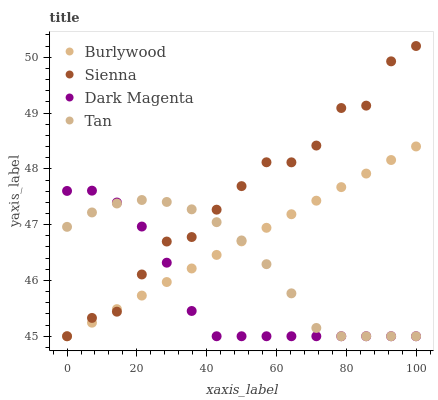Does Dark Magenta have the minimum area under the curve?
Answer yes or no. Yes. Does Sienna have the maximum area under the curve?
Answer yes or no. Yes. Does Tan have the minimum area under the curve?
Answer yes or no. No. Does Tan have the maximum area under the curve?
Answer yes or no. No. Is Burlywood the smoothest?
Answer yes or no. Yes. Is Sienna the roughest?
Answer yes or no. Yes. Is Tan the smoothest?
Answer yes or no. No. Is Tan the roughest?
Answer yes or no. No. Does Burlywood have the lowest value?
Answer yes or no. Yes. Does Sienna have the highest value?
Answer yes or no. Yes. Does Tan have the highest value?
Answer yes or no. No. Does Sienna intersect Burlywood?
Answer yes or no. Yes. Is Sienna less than Burlywood?
Answer yes or no. No. Is Sienna greater than Burlywood?
Answer yes or no. No. 